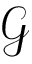Convert formula to latex. <formula><loc_0><loc_0><loc_500><loc_500>\mathcal { G }</formula> 